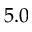Convert formula to latex. <formula><loc_0><loc_0><loc_500><loc_500>5 . 0</formula> 